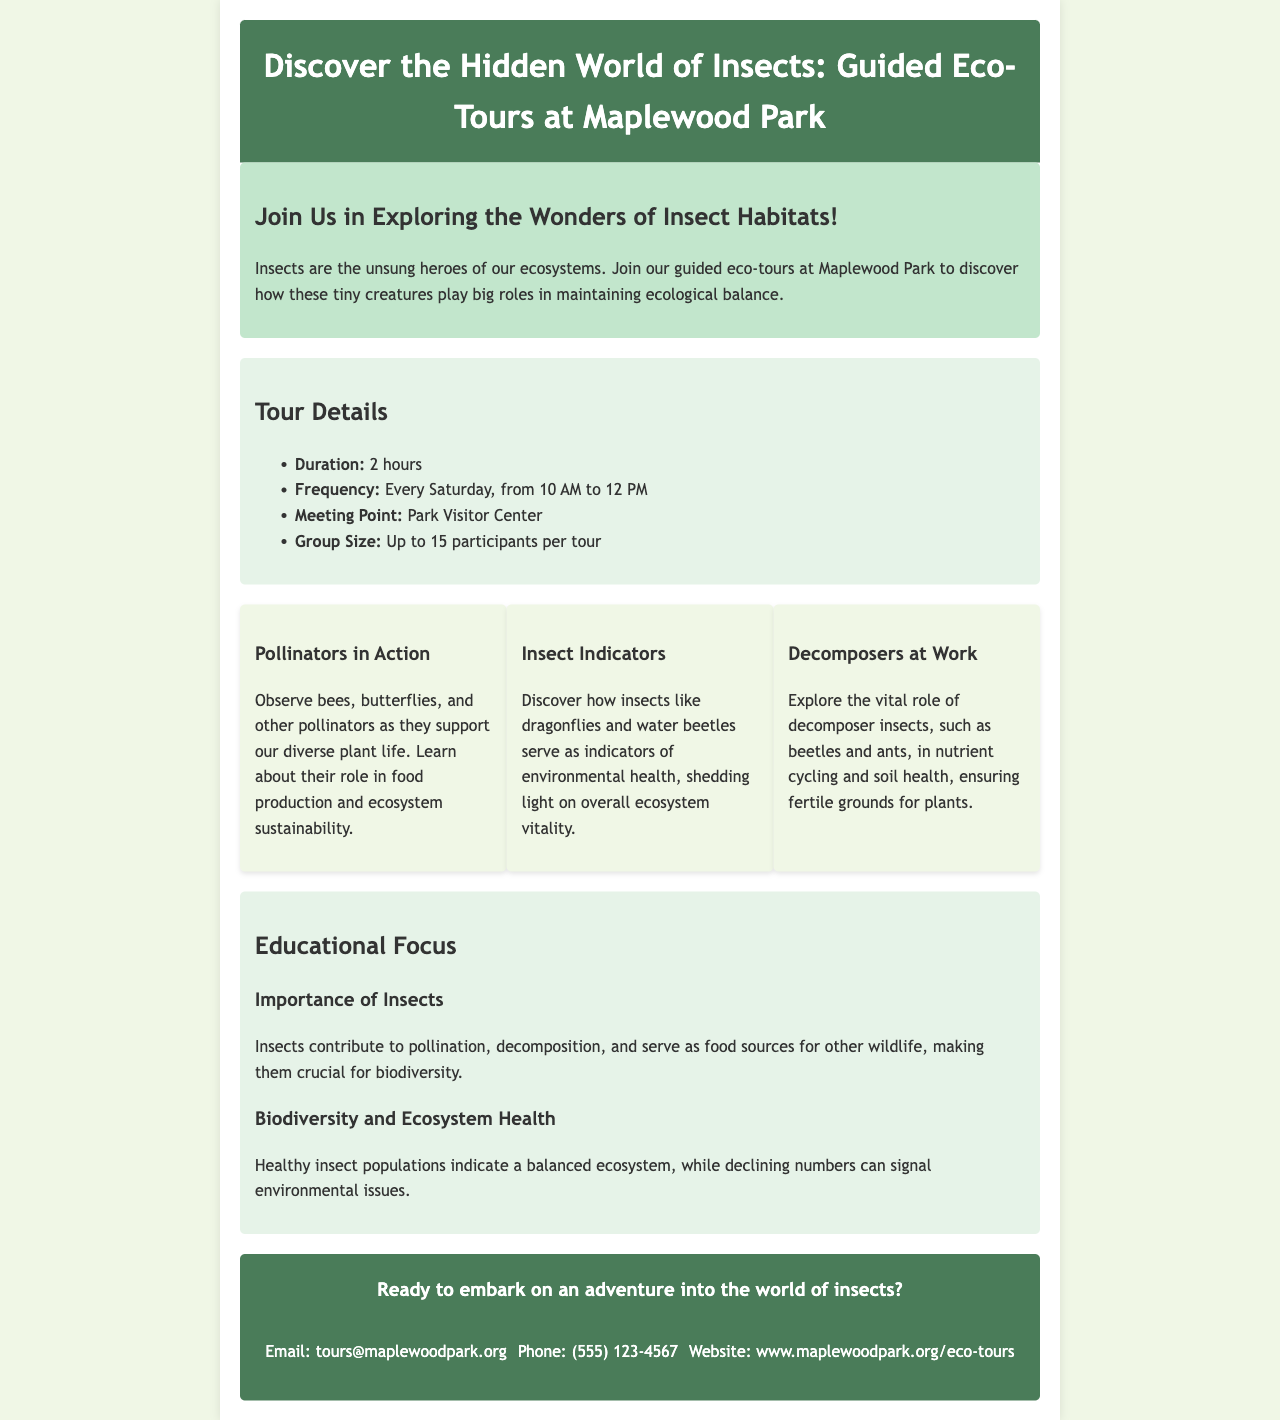What is the duration of the tour? The duration of the tour is specified in the document.
Answer: 2 hours When do the tours occur? The document states the frequency of the tours.
Answer: Every Saturday What is the meeting point for the tours? The document provides the meeting location for the tours.
Answer: Park Visitor Center How many participants are allowed in each tour? The document specifies the group size allowed for the tour.
Answer: Up to 15 participants Which pollinators can be observed during the tour? The document lists specific types of pollinators that can be seen.
Answer: Bees, butterflies What role do dragonflies serve according to the brochure? The document describes the role of dragonflies in relation to insects.
Answer: Indicators of environmental health Why are decomposer insects important? The document explains the significance of decomposer insects.
Answer: Nutrient cycling and soil health What is the educational focus of the tours? The document highlights the main educational topics discussed during the tour.
Answer: Importance of Insects, Biodiversity and Ecosystem Health What is the email address for inquiries? The document provides contact information for further questions.
Answer: tours@maplewoodpark.org 